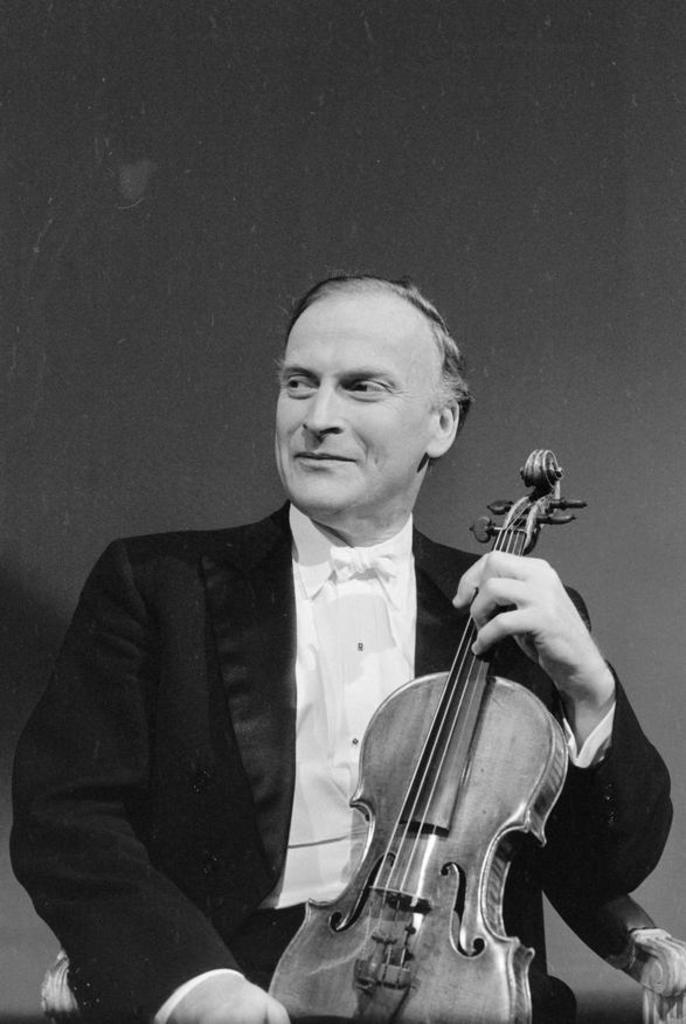What is the main subject of the image? There is a person in the image. What is the person doing in the image? The person is sitting on a chair and holding a violin. What is the person's facial expression in the image? The person is smiling. What type of star can be seen falling in the image? There is no star or falling star present in the image; it features a person sitting on a chair and holding a violin. What type of bomb is visible in the image? There is no bomb present in the image. 